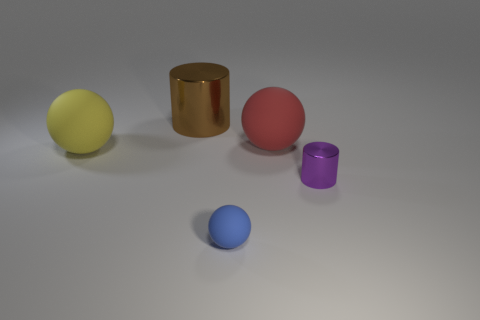What number of small purple cylinders are the same material as the large yellow sphere?
Make the answer very short. 0. Is the number of tiny metallic cylinders that are left of the brown thing less than the number of big cyan cubes?
Give a very brief answer. No. Are there any blue matte spheres behind the rubber object on the right side of the blue thing?
Your answer should be compact. No. Is there any other thing that is the same shape as the brown metallic thing?
Provide a short and direct response. Yes. Is the blue matte thing the same size as the red rubber ball?
Your response must be concise. No. What is the material of the thing that is in front of the cylinder that is in front of the metal cylinder that is behind the large yellow thing?
Your response must be concise. Rubber. Are there the same number of big yellow balls that are right of the yellow object and big brown matte things?
Offer a very short reply. Yes. How many objects are either cyan metallic objects or big spheres?
Your answer should be compact. 2. What shape is the other thing that is made of the same material as the purple object?
Your answer should be compact. Cylinder. There is a matte object that is to the left of the metallic cylinder left of the big red rubber ball; how big is it?
Provide a short and direct response. Large. 